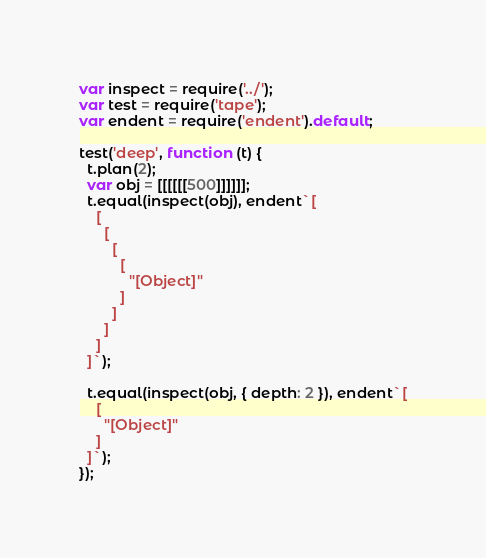<code> <loc_0><loc_0><loc_500><loc_500><_JavaScript_>var inspect = require('../');
var test = require('tape');
var endent = require('endent').default;

test('deep', function (t) {
  t.plan(2);
  var obj = [[[[[[500]]]]]];
  t.equal(inspect(obj), endent`[
    [
      [
        [
          [
            "[Object]"
          ]
        ]
      ]
    ]
  ]`);

  t.equal(inspect(obj, { depth: 2 }), endent`[
    [
      "[Object]"
    ]
  ]`);
});
</code> 